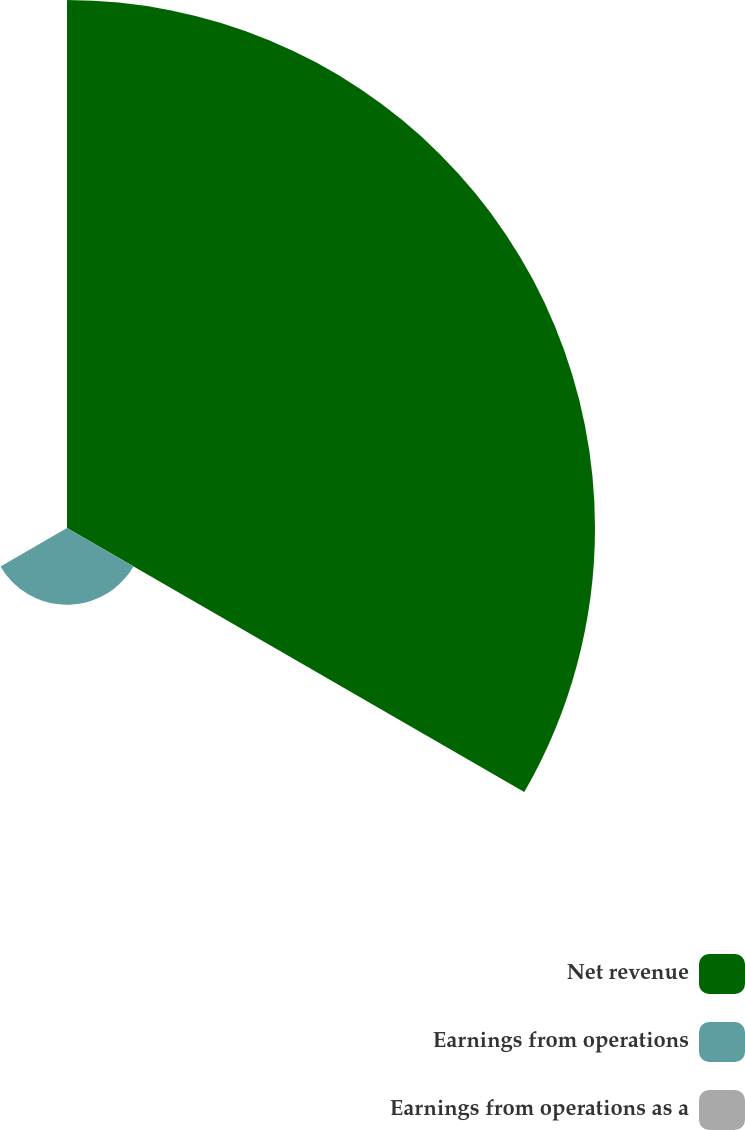Convert chart. <chart><loc_0><loc_0><loc_500><loc_500><pie_chart><fcel>Net revenue<fcel>Earnings from operations<fcel>Earnings from operations as a<nl><fcel>87.27%<fcel>12.69%<fcel>0.04%<nl></chart> 